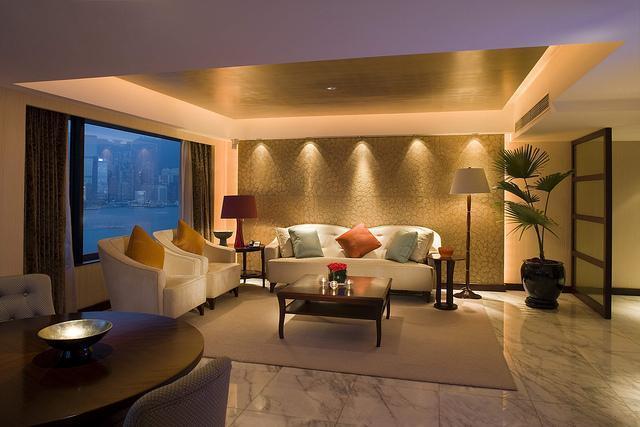How many stains are on the carpet?
Give a very brief answer. 0. How many couches can be seen?
Give a very brief answer. 3. How many chairs can be seen?
Give a very brief answer. 3. 